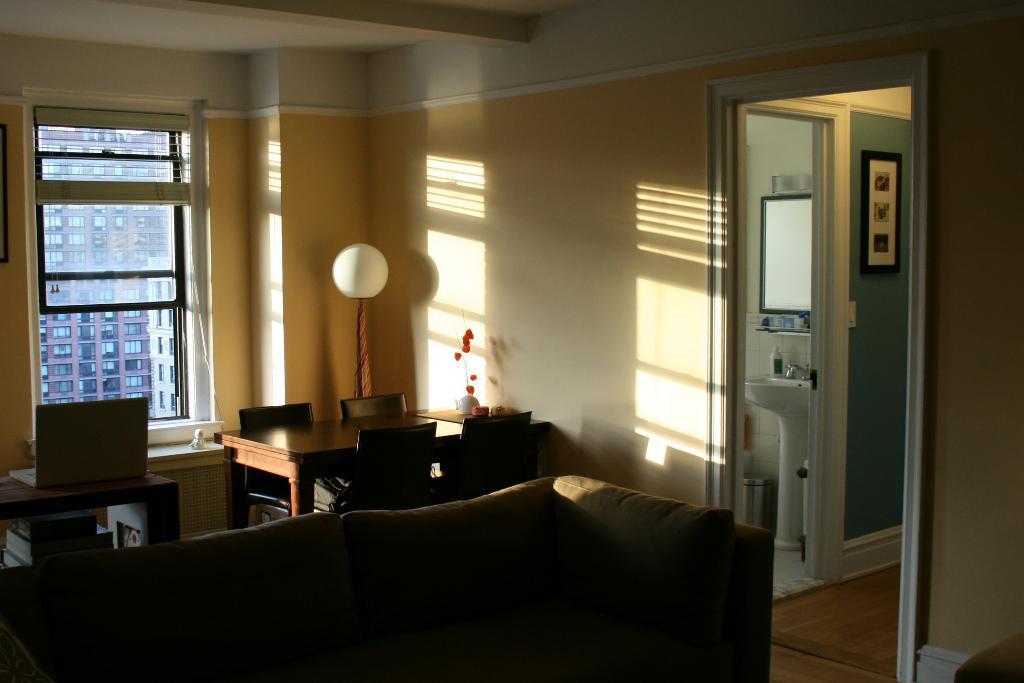Can you describe this image briefly? In this image I can see a couch,table and the chairs. On the table there is a laptop. In the background there is a window. To the right there is a sink and the frame to the wall. 